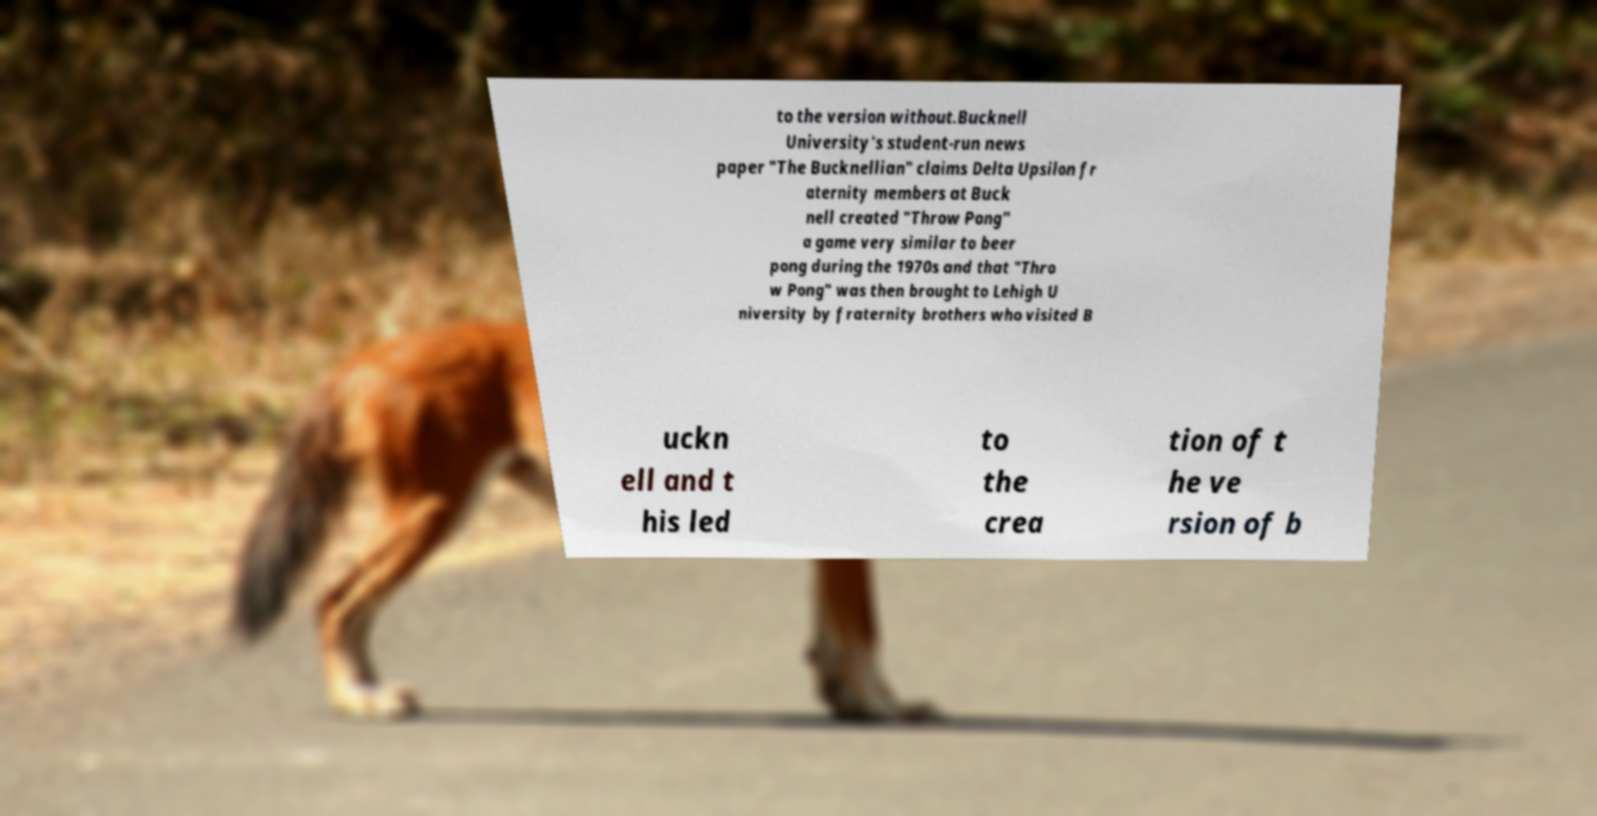Can you accurately transcribe the text from the provided image for me? to the version without.Bucknell University's student-run news paper "The Bucknellian" claims Delta Upsilon fr aternity members at Buck nell created "Throw Pong" a game very similar to beer pong during the 1970s and that "Thro w Pong" was then brought to Lehigh U niversity by fraternity brothers who visited B uckn ell and t his led to the crea tion of t he ve rsion of b 